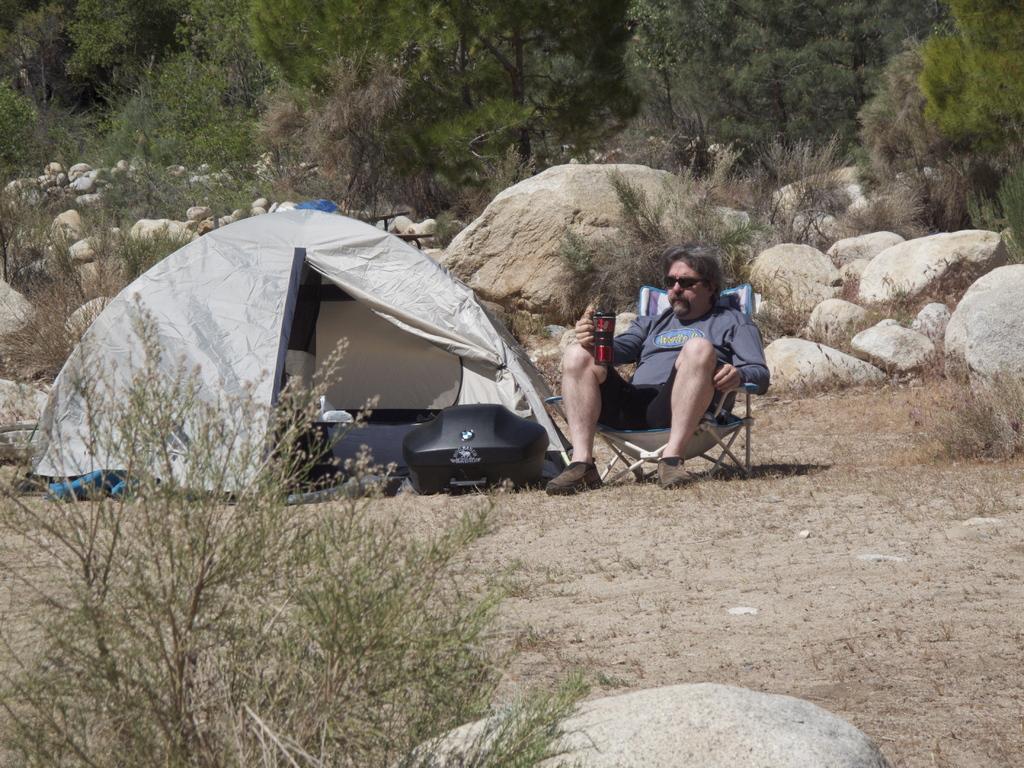Describe this image in one or two sentences. In this image we can see a man sitting on a chair holding a glass. We can also see a tent and a container beside him. On the backside we can see some plants, stones and a group of trees. 